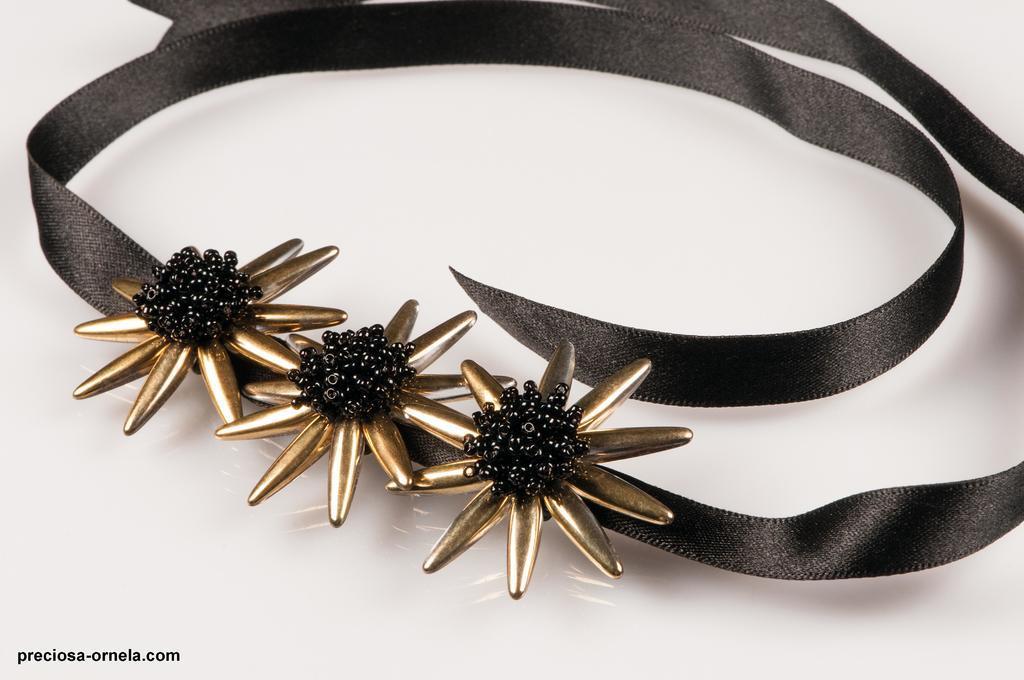Please provide a concise description of this image. This image consists of a ornament. It looks like a ribbon. It is in black color. It is kept on the desk. 